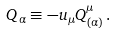<formula> <loc_0><loc_0><loc_500><loc_500>Q _ { \alpha } \equiv - u _ { \mu } Q ^ { \mu } _ { ( \alpha ) } \, .</formula> 